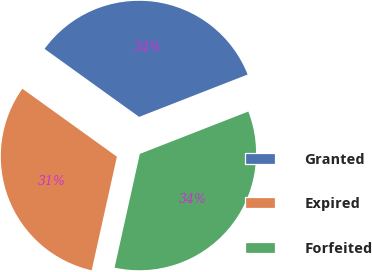Convert chart. <chart><loc_0><loc_0><loc_500><loc_500><pie_chart><fcel>Granted<fcel>Expired<fcel>Forfeited<nl><fcel>34.15%<fcel>31.44%<fcel>34.4%<nl></chart> 